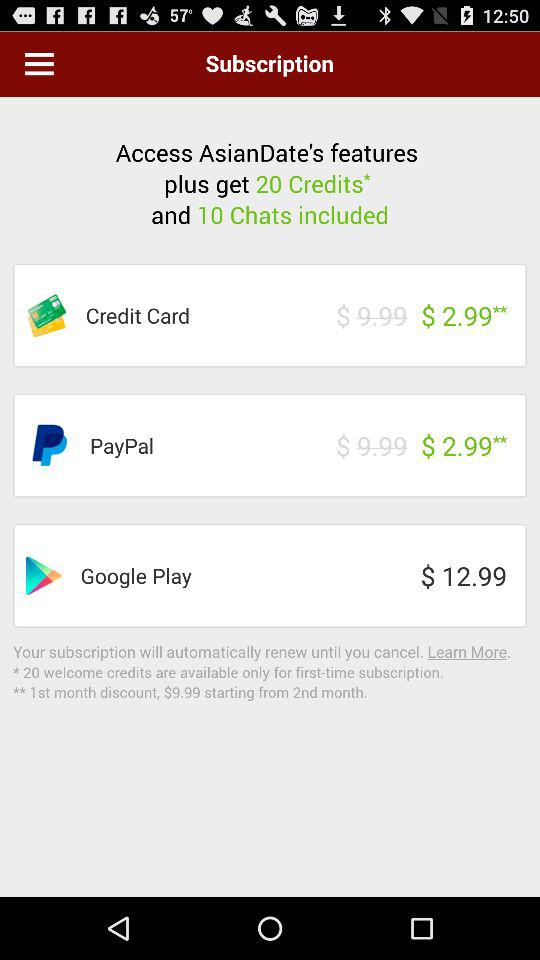What is the cost of the credit card? The cost of the credit card is $2.99. 